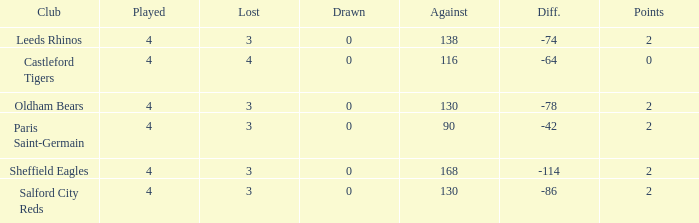What is the sum of losses for teams with less than 4 games played? None. 